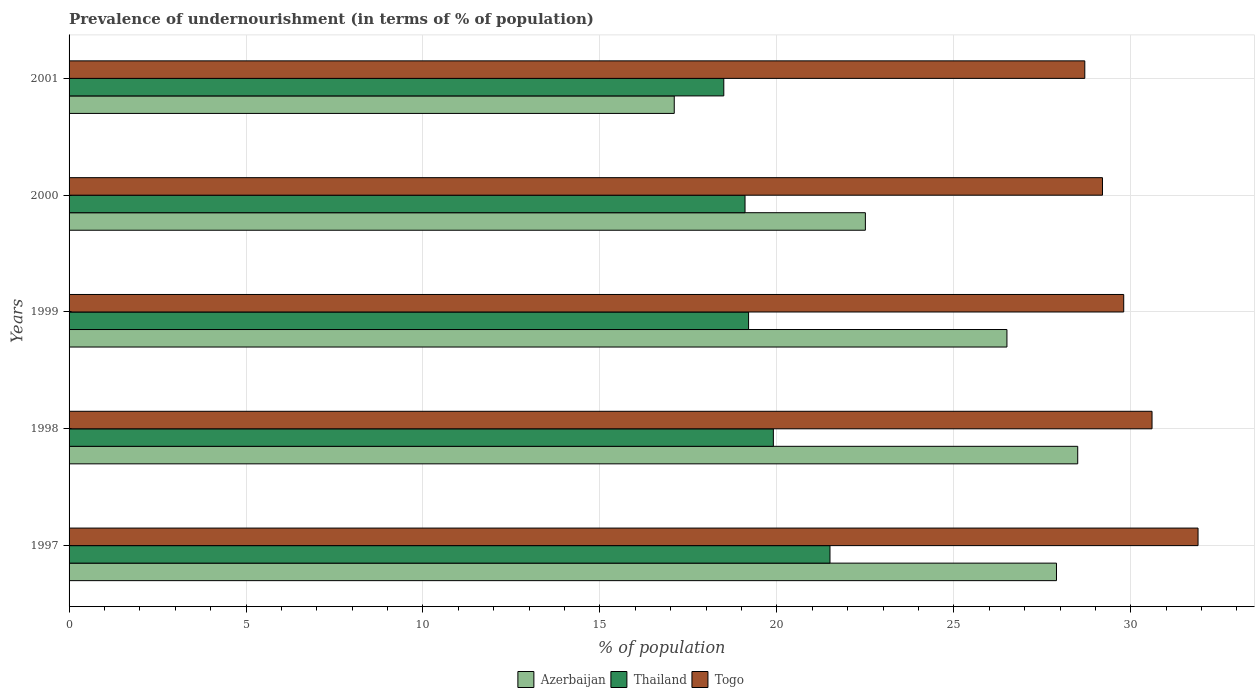How many different coloured bars are there?
Your answer should be very brief. 3. How many bars are there on the 5th tick from the top?
Ensure brevity in your answer.  3. What is the label of the 1st group of bars from the top?
Provide a succinct answer. 2001. Across all years, what is the maximum percentage of undernourished population in Togo?
Provide a succinct answer. 31.9. What is the total percentage of undernourished population in Thailand in the graph?
Give a very brief answer. 98.2. What is the difference between the percentage of undernourished population in Togo in 1997 and that in 1999?
Keep it short and to the point. 2.1. What is the difference between the percentage of undernourished population in Thailand in 1998 and the percentage of undernourished population in Togo in 1999?
Offer a very short reply. -9.9. What is the average percentage of undernourished population in Thailand per year?
Provide a short and direct response. 19.64. In the year 1999, what is the difference between the percentage of undernourished population in Togo and percentage of undernourished population in Azerbaijan?
Provide a succinct answer. 3.3. In how many years, is the percentage of undernourished population in Thailand greater than 20 %?
Keep it short and to the point. 1. What is the ratio of the percentage of undernourished population in Togo in 2000 to that in 2001?
Your answer should be compact. 1.02. Is the percentage of undernourished population in Togo in 1998 less than that in 1999?
Your answer should be very brief. No. What is the difference between the highest and the second highest percentage of undernourished population in Thailand?
Provide a short and direct response. 1.6. What is the difference between the highest and the lowest percentage of undernourished population in Thailand?
Your answer should be compact. 3. What does the 1st bar from the top in 1997 represents?
Ensure brevity in your answer.  Togo. What does the 2nd bar from the bottom in 2000 represents?
Your answer should be very brief. Thailand. Are all the bars in the graph horizontal?
Offer a terse response. Yes. Are the values on the major ticks of X-axis written in scientific E-notation?
Provide a short and direct response. No. What is the title of the graph?
Offer a terse response. Prevalence of undernourishment (in terms of % of population). What is the label or title of the X-axis?
Offer a very short reply. % of population. What is the label or title of the Y-axis?
Provide a succinct answer. Years. What is the % of population in Azerbaijan in 1997?
Offer a terse response. 27.9. What is the % of population in Togo in 1997?
Offer a very short reply. 31.9. What is the % of population of Thailand in 1998?
Your response must be concise. 19.9. What is the % of population in Togo in 1998?
Your answer should be compact. 30.6. What is the % of population in Thailand in 1999?
Offer a terse response. 19.2. What is the % of population of Togo in 1999?
Make the answer very short. 29.8. What is the % of population in Thailand in 2000?
Ensure brevity in your answer.  19.1. What is the % of population of Togo in 2000?
Your answer should be very brief. 29.2. What is the % of population of Azerbaijan in 2001?
Your answer should be very brief. 17.1. What is the % of population of Thailand in 2001?
Give a very brief answer. 18.5. What is the % of population in Togo in 2001?
Provide a succinct answer. 28.7. Across all years, what is the maximum % of population of Azerbaijan?
Offer a very short reply. 28.5. Across all years, what is the maximum % of population of Togo?
Make the answer very short. 31.9. Across all years, what is the minimum % of population of Azerbaijan?
Provide a short and direct response. 17.1. Across all years, what is the minimum % of population in Togo?
Offer a terse response. 28.7. What is the total % of population in Azerbaijan in the graph?
Make the answer very short. 122.5. What is the total % of population in Thailand in the graph?
Make the answer very short. 98.2. What is the total % of population in Togo in the graph?
Your answer should be very brief. 150.2. What is the difference between the % of population in Togo in 1997 and that in 1998?
Keep it short and to the point. 1.3. What is the difference between the % of population of Azerbaijan in 1997 and that in 2000?
Your answer should be very brief. 5.4. What is the difference between the % of population of Thailand in 1997 and that in 2000?
Keep it short and to the point. 2.4. What is the difference between the % of population in Thailand in 1997 and that in 2001?
Give a very brief answer. 3. What is the difference between the % of population in Togo in 1997 and that in 2001?
Make the answer very short. 3.2. What is the difference between the % of population in Azerbaijan in 1998 and that in 1999?
Your answer should be compact. 2. What is the difference between the % of population in Thailand in 1998 and that in 2000?
Give a very brief answer. 0.8. What is the difference between the % of population of Togo in 1998 and that in 2000?
Ensure brevity in your answer.  1.4. What is the difference between the % of population in Azerbaijan in 1998 and that in 2001?
Make the answer very short. 11.4. What is the difference between the % of population of Azerbaijan in 1999 and that in 2000?
Offer a very short reply. 4. What is the difference between the % of population of Togo in 1999 and that in 2000?
Your answer should be very brief. 0.6. What is the difference between the % of population of Thailand in 1999 and that in 2001?
Provide a succinct answer. 0.7. What is the difference between the % of population of Thailand in 1997 and the % of population of Togo in 1999?
Your response must be concise. -8.3. What is the difference between the % of population of Azerbaijan in 1997 and the % of population of Togo in 2000?
Your answer should be very brief. -1.3. What is the difference between the % of population in Thailand in 1997 and the % of population in Togo in 2000?
Provide a short and direct response. -7.7. What is the difference between the % of population of Azerbaijan in 1998 and the % of population of Thailand in 1999?
Ensure brevity in your answer.  9.3. What is the difference between the % of population of Azerbaijan in 1998 and the % of population of Togo in 1999?
Your answer should be compact. -1.3. What is the difference between the % of population in Thailand in 1998 and the % of population in Togo in 1999?
Make the answer very short. -9.9. What is the difference between the % of population in Azerbaijan in 1998 and the % of population in Thailand in 2000?
Ensure brevity in your answer.  9.4. What is the difference between the % of population in Azerbaijan in 1998 and the % of population in Thailand in 2001?
Make the answer very short. 10. What is the difference between the % of population of Azerbaijan in 1998 and the % of population of Togo in 2001?
Offer a very short reply. -0.2. What is the difference between the % of population in Azerbaijan in 1999 and the % of population in Thailand in 2001?
Give a very brief answer. 8. What is the difference between the % of population in Azerbaijan in 1999 and the % of population in Togo in 2001?
Your answer should be very brief. -2.2. What is the difference between the % of population of Thailand in 1999 and the % of population of Togo in 2001?
Your response must be concise. -9.5. What is the difference between the % of population of Azerbaijan in 2000 and the % of population of Thailand in 2001?
Your answer should be compact. 4. What is the average % of population in Azerbaijan per year?
Keep it short and to the point. 24.5. What is the average % of population in Thailand per year?
Ensure brevity in your answer.  19.64. What is the average % of population of Togo per year?
Give a very brief answer. 30.04. In the year 1997, what is the difference between the % of population in Azerbaijan and % of population in Thailand?
Offer a terse response. 6.4. In the year 1997, what is the difference between the % of population in Azerbaijan and % of population in Togo?
Ensure brevity in your answer.  -4. In the year 1998, what is the difference between the % of population of Azerbaijan and % of population of Togo?
Your answer should be very brief. -2.1. In the year 1998, what is the difference between the % of population of Thailand and % of population of Togo?
Provide a short and direct response. -10.7. In the year 1999, what is the difference between the % of population of Azerbaijan and % of population of Thailand?
Your answer should be compact. 7.3. In the year 1999, what is the difference between the % of population of Azerbaijan and % of population of Togo?
Offer a terse response. -3.3. In the year 2000, what is the difference between the % of population in Thailand and % of population in Togo?
Ensure brevity in your answer.  -10.1. What is the ratio of the % of population of Azerbaijan in 1997 to that in 1998?
Make the answer very short. 0.98. What is the ratio of the % of population in Thailand in 1997 to that in 1998?
Your answer should be compact. 1.08. What is the ratio of the % of population of Togo in 1997 to that in 1998?
Offer a terse response. 1.04. What is the ratio of the % of population in Azerbaijan in 1997 to that in 1999?
Make the answer very short. 1.05. What is the ratio of the % of population in Thailand in 1997 to that in 1999?
Give a very brief answer. 1.12. What is the ratio of the % of population in Togo in 1997 to that in 1999?
Ensure brevity in your answer.  1.07. What is the ratio of the % of population in Azerbaijan in 1997 to that in 2000?
Provide a succinct answer. 1.24. What is the ratio of the % of population of Thailand in 1997 to that in 2000?
Your response must be concise. 1.13. What is the ratio of the % of population of Togo in 1997 to that in 2000?
Your answer should be compact. 1.09. What is the ratio of the % of population of Azerbaijan in 1997 to that in 2001?
Offer a very short reply. 1.63. What is the ratio of the % of population in Thailand in 1997 to that in 2001?
Keep it short and to the point. 1.16. What is the ratio of the % of population of Togo in 1997 to that in 2001?
Keep it short and to the point. 1.11. What is the ratio of the % of population in Azerbaijan in 1998 to that in 1999?
Provide a short and direct response. 1.08. What is the ratio of the % of population in Thailand in 1998 to that in 1999?
Keep it short and to the point. 1.04. What is the ratio of the % of population in Togo in 1998 to that in 1999?
Provide a succinct answer. 1.03. What is the ratio of the % of population in Azerbaijan in 1998 to that in 2000?
Offer a terse response. 1.27. What is the ratio of the % of population in Thailand in 1998 to that in 2000?
Your answer should be very brief. 1.04. What is the ratio of the % of population in Togo in 1998 to that in 2000?
Your answer should be compact. 1.05. What is the ratio of the % of population of Azerbaijan in 1998 to that in 2001?
Provide a succinct answer. 1.67. What is the ratio of the % of population of Thailand in 1998 to that in 2001?
Provide a short and direct response. 1.08. What is the ratio of the % of population of Togo in 1998 to that in 2001?
Your answer should be compact. 1.07. What is the ratio of the % of population of Azerbaijan in 1999 to that in 2000?
Offer a very short reply. 1.18. What is the ratio of the % of population in Togo in 1999 to that in 2000?
Give a very brief answer. 1.02. What is the ratio of the % of population in Azerbaijan in 1999 to that in 2001?
Keep it short and to the point. 1.55. What is the ratio of the % of population of Thailand in 1999 to that in 2001?
Provide a short and direct response. 1.04. What is the ratio of the % of population in Togo in 1999 to that in 2001?
Offer a very short reply. 1.04. What is the ratio of the % of population in Azerbaijan in 2000 to that in 2001?
Your answer should be very brief. 1.32. What is the ratio of the % of population in Thailand in 2000 to that in 2001?
Offer a very short reply. 1.03. What is the ratio of the % of population of Togo in 2000 to that in 2001?
Provide a short and direct response. 1.02. What is the difference between the highest and the second highest % of population in Thailand?
Your answer should be compact. 1.6. What is the difference between the highest and the second highest % of population of Togo?
Your answer should be compact. 1.3. What is the difference between the highest and the lowest % of population of Togo?
Your answer should be very brief. 3.2. 